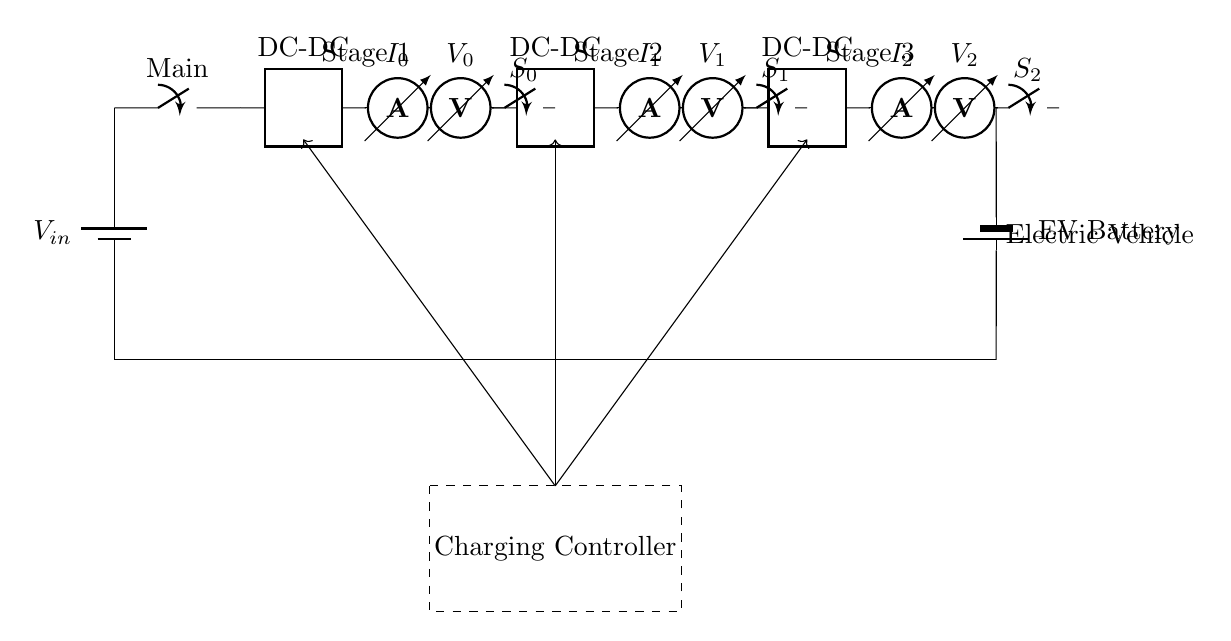What is the input voltage of the circuit? The input voltage is labeled as V_in, which indicates the source voltage to power the circuit.
Answer: V_in How many stages are present in the charging circuit? The circuit diagram shows three distinct stages, labeled Stage 1, Stage 2, and Stage 3. Each stage corresponds to a different DC-DC converter.
Answer: 3 What type of components are used in each stage for voltage and current measurement? Each stage includes an ammeter for current measurement and a voltmeter for voltage measurement, as indicated in the diagram.
Answer: Ammeter and Voltmeter What is the purpose of the charging controller shown in the circuit? The charging controller oversees the operation of the entire charging process, managing the switches and converters based on operational parameters.
Answer: Manage charging Which component connects all three stages together? The switch labeled S_x connects each stage in series, allowing for the control of electricity flow between stages.
Answer: Switch What is the output of the charging circuit? The output is the electric vehicle battery, which is represented as a battery2 component in the diagram indicating that it stores the charge collected from the stages.
Answer: Electric Vehicle Battery Which component regulates voltage conversion in the circuit? The DC-DC converter in each stage regulates voltage conversion, making it suitable for charging the electric vehicle's battery safely and efficiently.
Answer: DC-DC Converter 